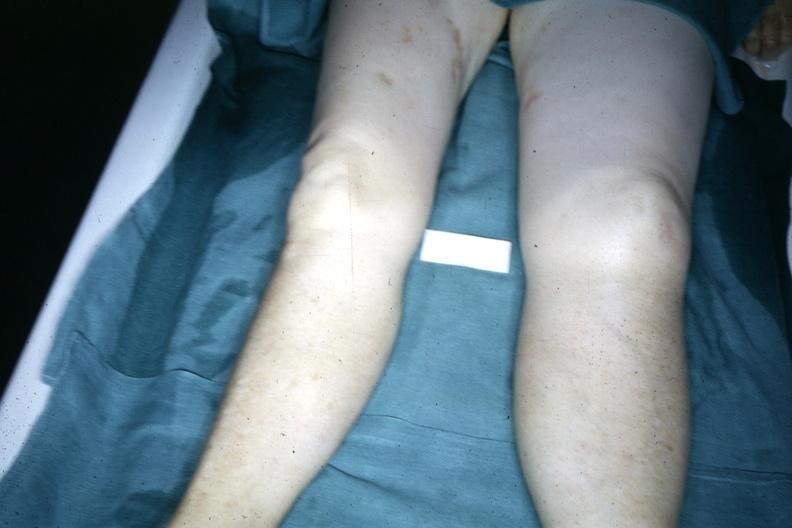what is legs demonstrated?
Answer the question using a single word or phrase. With one about twice the size of the other due to malignant lymphoma involving lymphatic drainage 